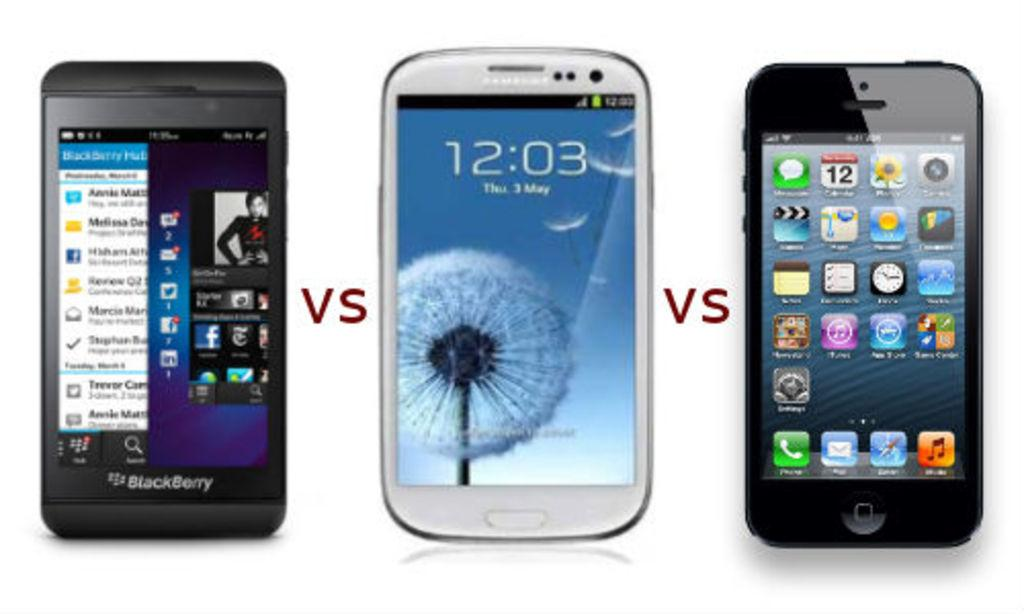<image>
Give a short and clear explanation of the subsequent image. three phones, one of which is displaying the time 12.03 